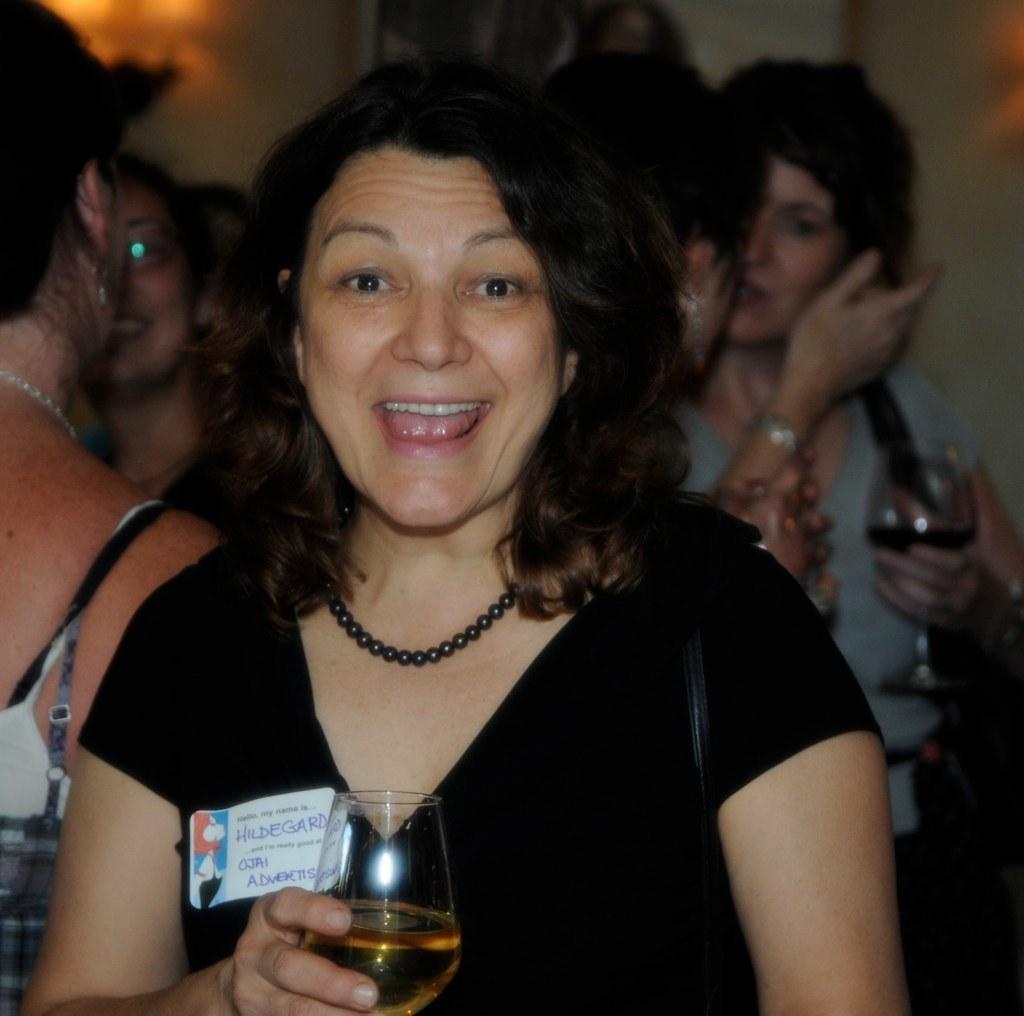Could you give a brief overview of what you see in this image? There are group of persons in this image at the foreground there is a woman wearing a black color T-shirt standing and holding a wine glass and at the backside of the image there are group of lady persons and at the right side of the image there is a lady person holding a wine glass. 